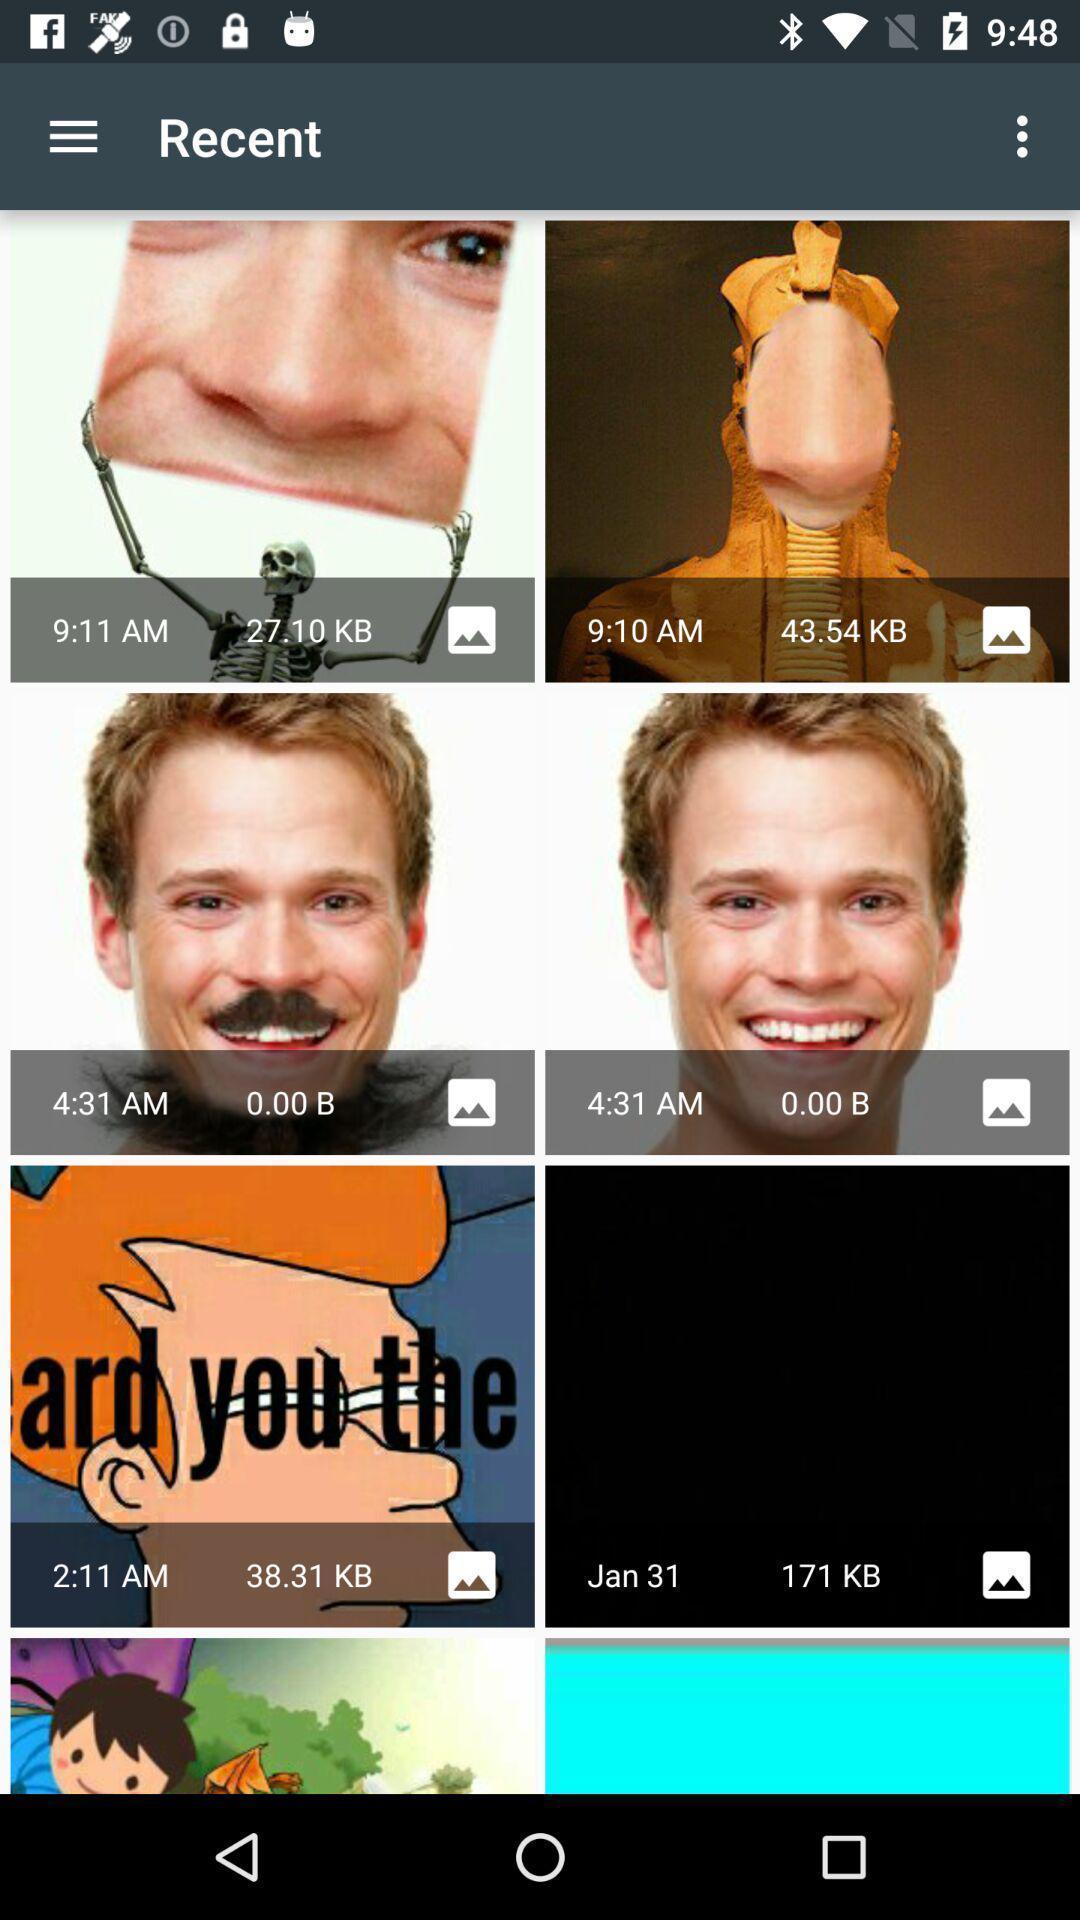Please provide a description for this image. Page showing list of different images. 